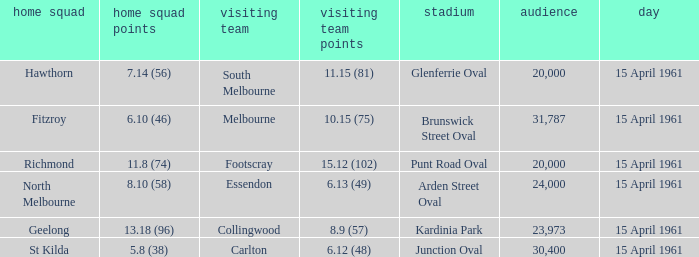What is the average crowd size when Collingwood is the away team? 23973.0. 